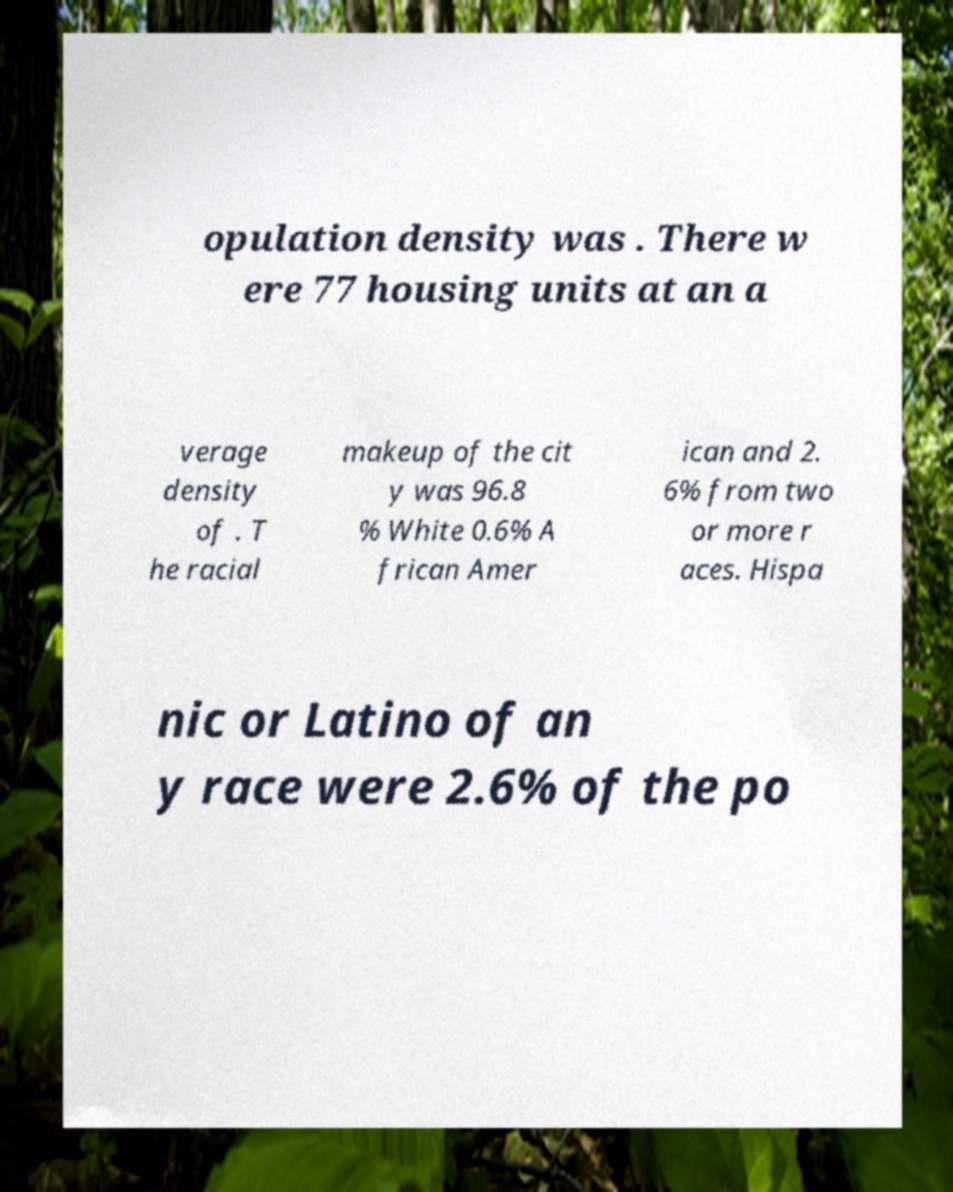Please identify and transcribe the text found in this image. opulation density was . There w ere 77 housing units at an a verage density of . T he racial makeup of the cit y was 96.8 % White 0.6% A frican Amer ican and 2. 6% from two or more r aces. Hispa nic or Latino of an y race were 2.6% of the po 